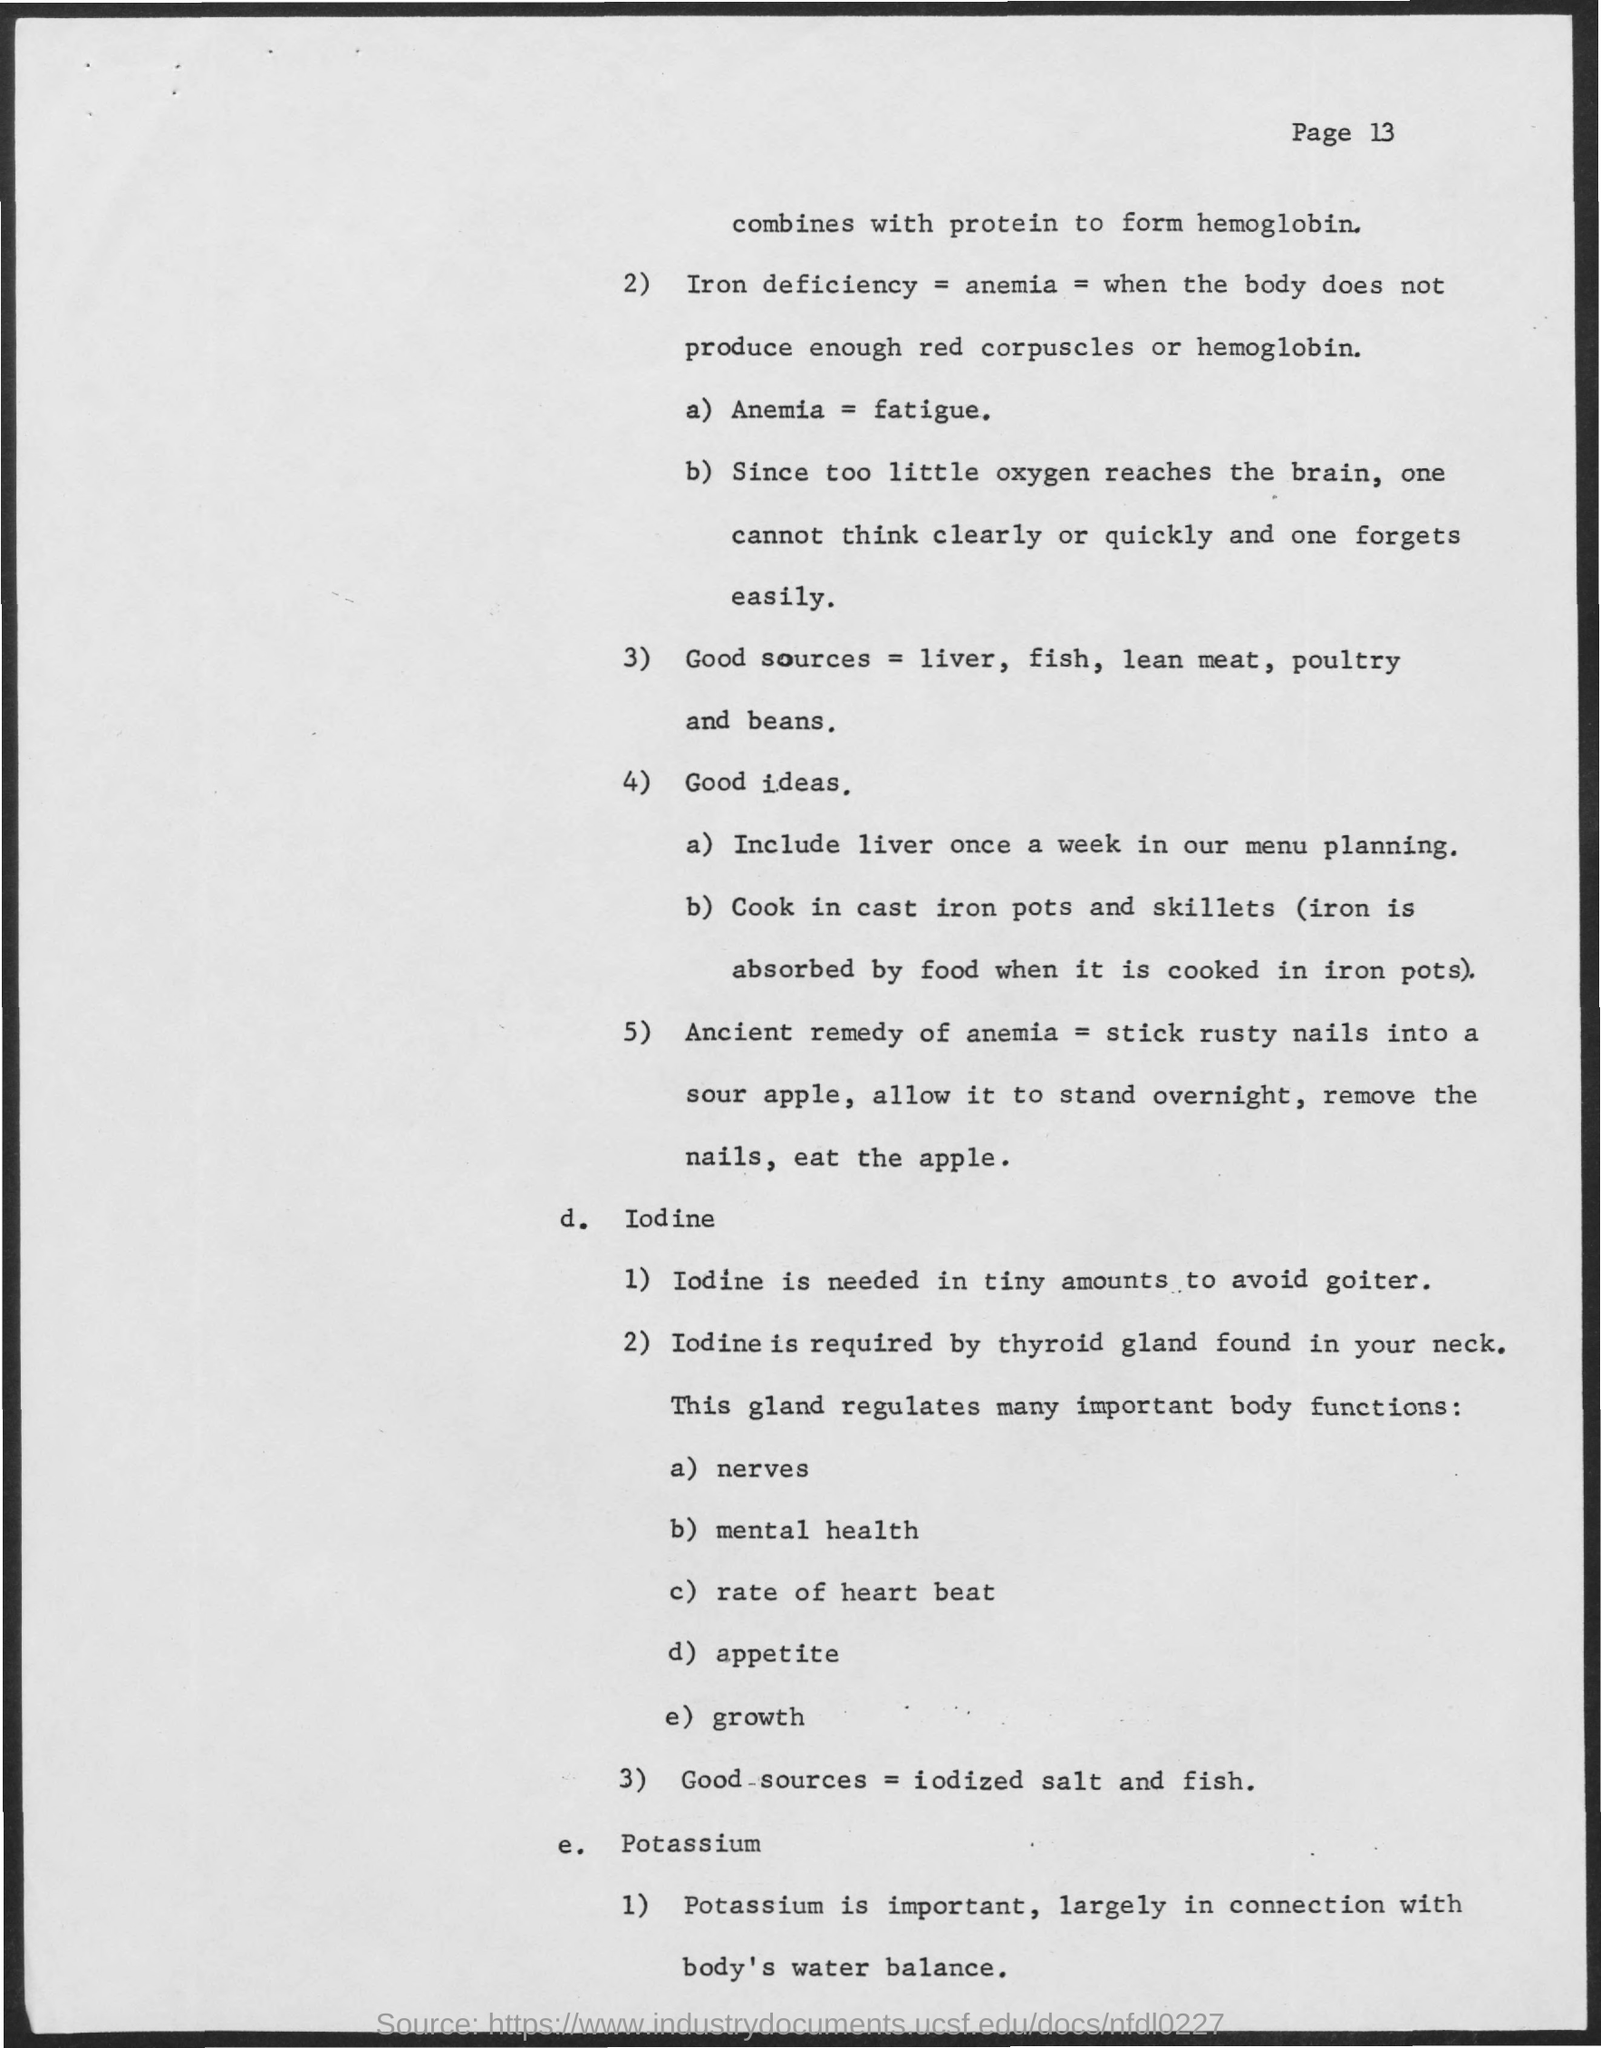Specify some key components in this picture. One cannot think clearly or quickly due to a lack of oxygen reaching the brain. 